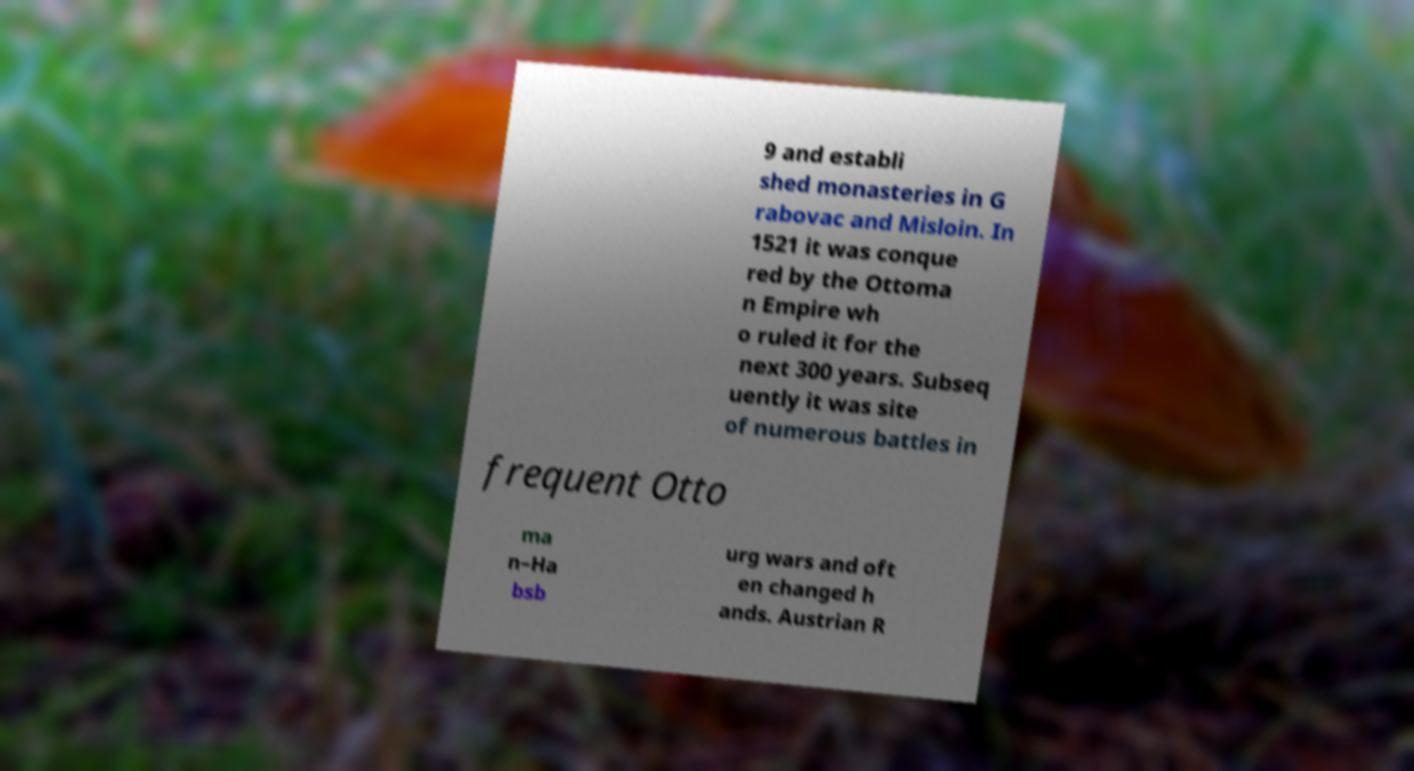Could you extract and type out the text from this image? 9 and establi shed monasteries in G rabovac and Misloin. In 1521 it was conque red by the Ottoma n Empire wh o ruled it for the next 300 years. Subseq uently it was site of numerous battles in frequent Otto ma n–Ha bsb urg wars and oft en changed h ands. Austrian R 